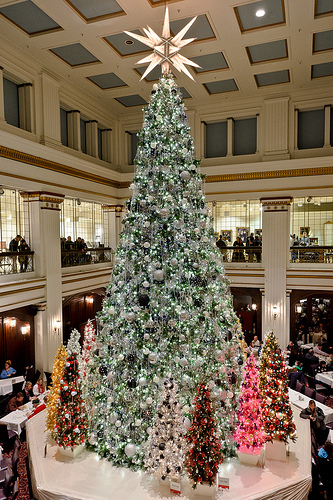<image>
Is the tree in front of the people? Yes. The tree is positioned in front of the people, appearing closer to the camera viewpoint. Is there a person above the tree? No. The person is not positioned above the tree. The vertical arrangement shows a different relationship. 